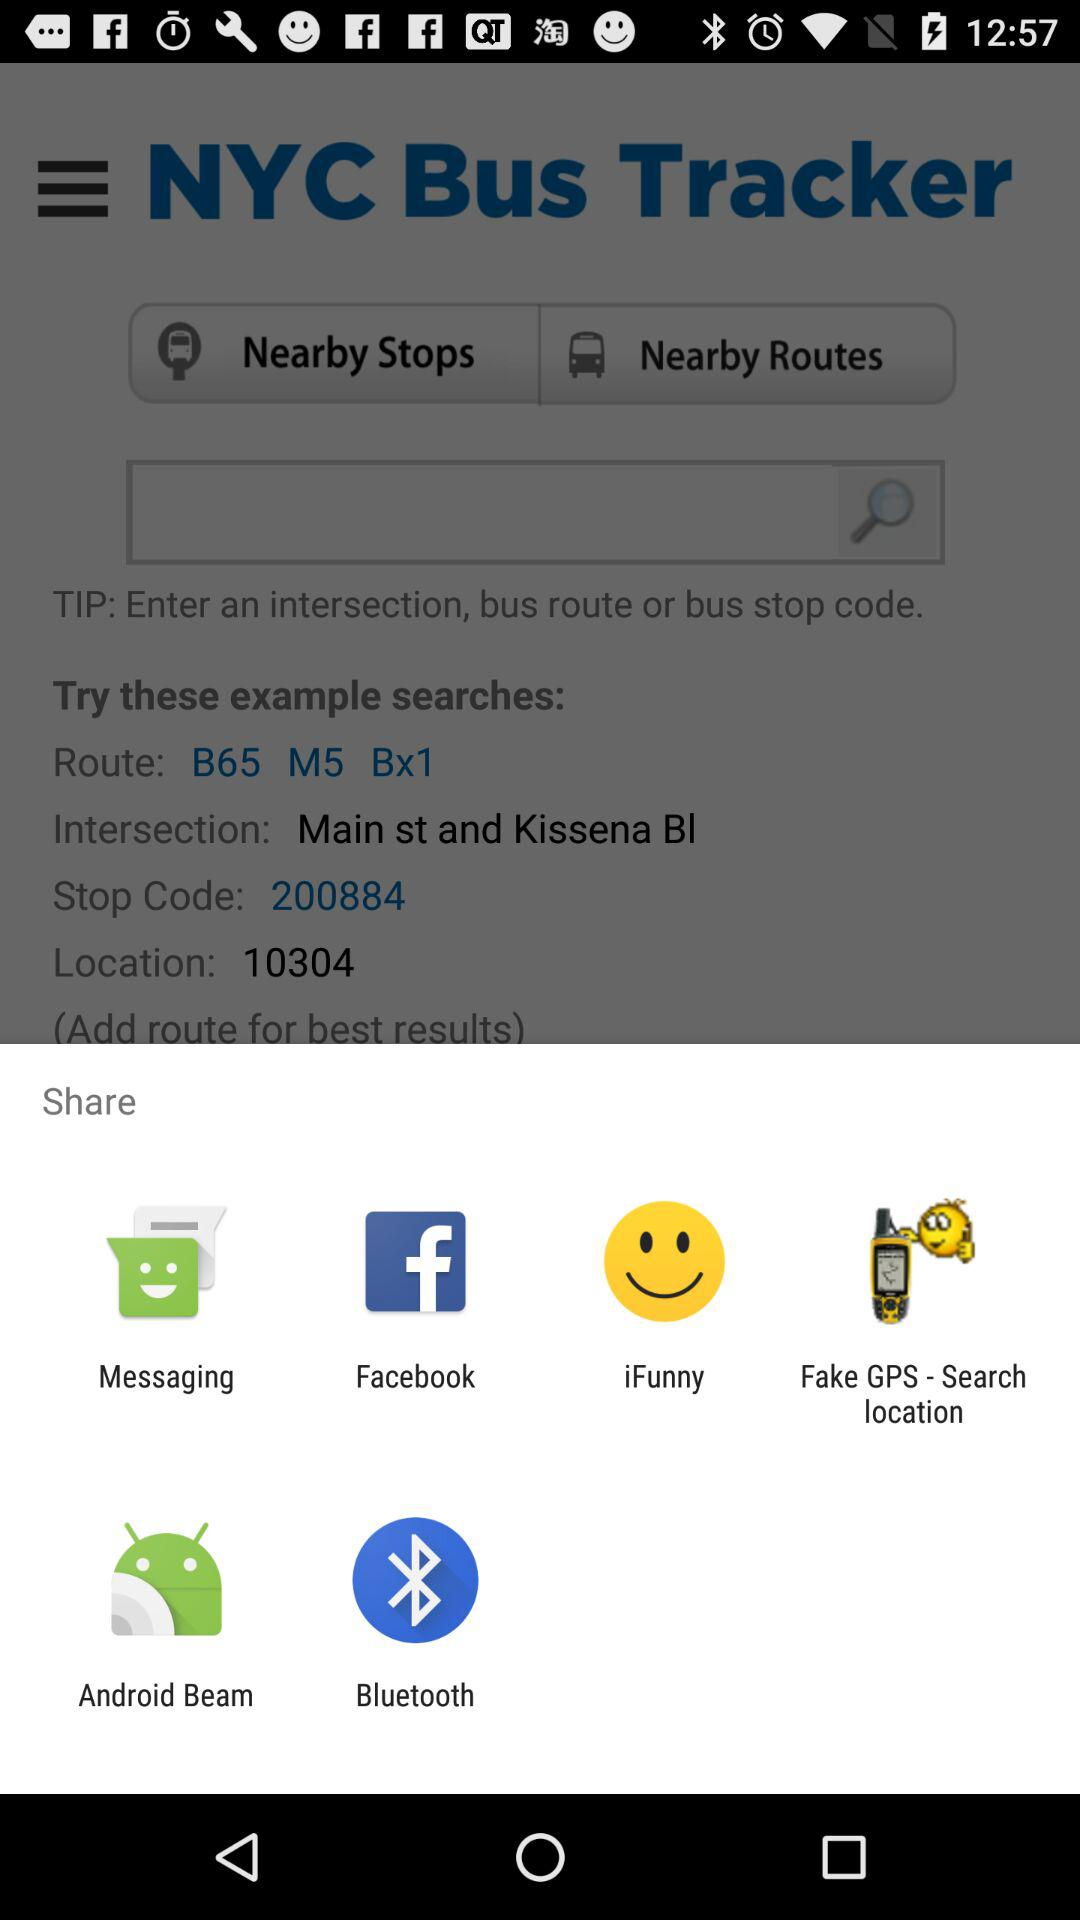What is the example of the bus route? The bus route is B65 M5 Bx1. 